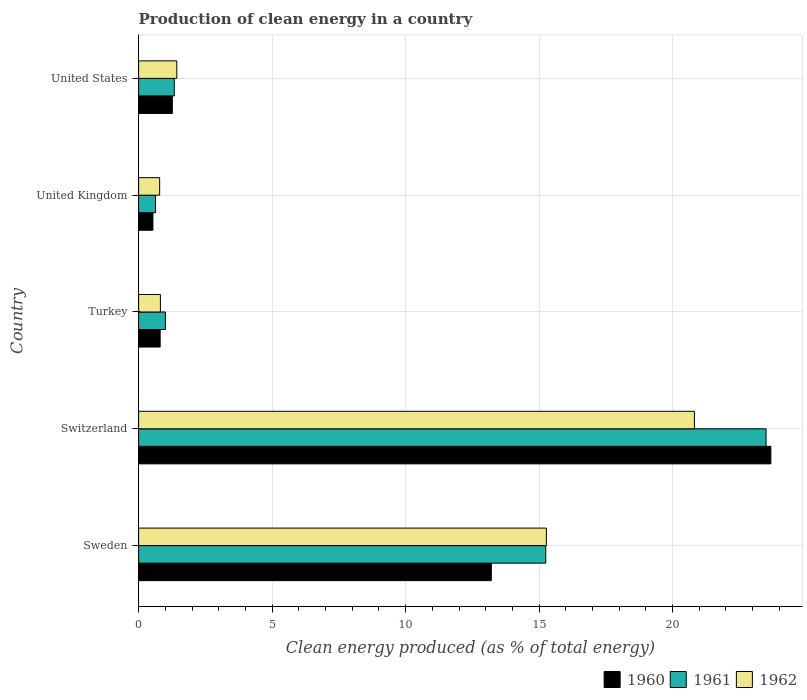How many different coloured bars are there?
Your response must be concise. 3. Are the number of bars per tick equal to the number of legend labels?
Your response must be concise. Yes. How many bars are there on the 1st tick from the top?
Offer a terse response. 3. How many bars are there on the 2nd tick from the bottom?
Offer a terse response. 3. What is the label of the 4th group of bars from the top?
Give a very brief answer. Switzerland. In how many cases, is the number of bars for a given country not equal to the number of legend labels?
Keep it short and to the point. 0. What is the percentage of clean energy produced in 1962 in Switzerland?
Your response must be concise. 20.82. Across all countries, what is the maximum percentage of clean energy produced in 1961?
Provide a short and direct response. 23.5. Across all countries, what is the minimum percentage of clean energy produced in 1960?
Your answer should be compact. 0.54. In which country was the percentage of clean energy produced in 1960 maximum?
Make the answer very short. Switzerland. In which country was the percentage of clean energy produced in 1960 minimum?
Your answer should be very brief. United Kingdom. What is the total percentage of clean energy produced in 1960 in the graph?
Keep it short and to the point. 39.5. What is the difference between the percentage of clean energy produced in 1962 in Turkey and that in United Kingdom?
Keep it short and to the point. 0.03. What is the difference between the percentage of clean energy produced in 1961 in United States and the percentage of clean energy produced in 1960 in Switzerland?
Your response must be concise. -22.35. What is the average percentage of clean energy produced in 1961 per country?
Provide a short and direct response. 8.34. What is the difference between the percentage of clean energy produced in 1961 and percentage of clean energy produced in 1960 in Switzerland?
Your answer should be very brief. -0.18. In how many countries, is the percentage of clean energy produced in 1961 greater than 11 %?
Keep it short and to the point. 2. What is the ratio of the percentage of clean energy produced in 1962 in Sweden to that in Switzerland?
Offer a very short reply. 0.73. What is the difference between the highest and the second highest percentage of clean energy produced in 1961?
Your answer should be compact. 8.25. What is the difference between the highest and the lowest percentage of clean energy produced in 1960?
Ensure brevity in your answer.  23.15. Is the sum of the percentage of clean energy produced in 1960 in Sweden and Turkey greater than the maximum percentage of clean energy produced in 1962 across all countries?
Ensure brevity in your answer.  No. What does the 2nd bar from the top in Sweden represents?
Your answer should be compact. 1961. What does the 3rd bar from the bottom in Switzerland represents?
Offer a terse response. 1962. Is it the case that in every country, the sum of the percentage of clean energy produced in 1962 and percentage of clean energy produced in 1960 is greater than the percentage of clean energy produced in 1961?
Provide a short and direct response. Yes. What is the difference between two consecutive major ticks on the X-axis?
Provide a succinct answer. 5. Where does the legend appear in the graph?
Your answer should be compact. Bottom right. What is the title of the graph?
Your response must be concise. Production of clean energy in a country. What is the label or title of the X-axis?
Keep it short and to the point. Clean energy produced (as % of total energy). What is the Clean energy produced (as % of total energy) of 1960 in Sweden?
Give a very brief answer. 13.21. What is the Clean energy produced (as % of total energy) in 1961 in Sweden?
Give a very brief answer. 15.25. What is the Clean energy produced (as % of total energy) of 1962 in Sweden?
Ensure brevity in your answer.  15.27. What is the Clean energy produced (as % of total energy) in 1960 in Switzerland?
Your answer should be compact. 23.68. What is the Clean energy produced (as % of total energy) in 1961 in Switzerland?
Your answer should be very brief. 23.5. What is the Clean energy produced (as % of total energy) of 1962 in Switzerland?
Your response must be concise. 20.82. What is the Clean energy produced (as % of total energy) in 1960 in Turkey?
Your response must be concise. 0.81. What is the Clean energy produced (as % of total energy) in 1961 in Turkey?
Give a very brief answer. 1. What is the Clean energy produced (as % of total energy) in 1962 in Turkey?
Provide a short and direct response. 0.82. What is the Clean energy produced (as % of total energy) in 1960 in United Kingdom?
Provide a short and direct response. 0.54. What is the Clean energy produced (as % of total energy) of 1961 in United Kingdom?
Offer a very short reply. 0.63. What is the Clean energy produced (as % of total energy) in 1962 in United Kingdom?
Ensure brevity in your answer.  0.79. What is the Clean energy produced (as % of total energy) in 1960 in United States?
Give a very brief answer. 1.26. What is the Clean energy produced (as % of total energy) of 1961 in United States?
Provide a short and direct response. 1.33. What is the Clean energy produced (as % of total energy) of 1962 in United States?
Your response must be concise. 1.43. Across all countries, what is the maximum Clean energy produced (as % of total energy) in 1960?
Your answer should be very brief. 23.68. Across all countries, what is the maximum Clean energy produced (as % of total energy) of 1961?
Offer a terse response. 23.5. Across all countries, what is the maximum Clean energy produced (as % of total energy) of 1962?
Give a very brief answer. 20.82. Across all countries, what is the minimum Clean energy produced (as % of total energy) of 1960?
Give a very brief answer. 0.54. Across all countries, what is the minimum Clean energy produced (as % of total energy) of 1961?
Your response must be concise. 0.63. Across all countries, what is the minimum Clean energy produced (as % of total energy) in 1962?
Your answer should be very brief. 0.79. What is the total Clean energy produced (as % of total energy) of 1960 in the graph?
Your answer should be very brief. 39.5. What is the total Clean energy produced (as % of total energy) of 1961 in the graph?
Offer a terse response. 41.72. What is the total Clean energy produced (as % of total energy) of 1962 in the graph?
Ensure brevity in your answer.  39.12. What is the difference between the Clean energy produced (as % of total energy) of 1960 in Sweden and that in Switzerland?
Give a very brief answer. -10.47. What is the difference between the Clean energy produced (as % of total energy) in 1961 in Sweden and that in Switzerland?
Give a very brief answer. -8.25. What is the difference between the Clean energy produced (as % of total energy) in 1962 in Sweden and that in Switzerland?
Your answer should be compact. -5.55. What is the difference between the Clean energy produced (as % of total energy) in 1960 in Sweden and that in Turkey?
Offer a very short reply. 12.4. What is the difference between the Clean energy produced (as % of total energy) of 1961 in Sweden and that in Turkey?
Your response must be concise. 14.25. What is the difference between the Clean energy produced (as % of total energy) in 1962 in Sweden and that in Turkey?
Provide a succinct answer. 14.46. What is the difference between the Clean energy produced (as % of total energy) of 1960 in Sweden and that in United Kingdom?
Your answer should be very brief. 12.68. What is the difference between the Clean energy produced (as % of total energy) in 1961 in Sweden and that in United Kingdom?
Offer a terse response. 14.62. What is the difference between the Clean energy produced (as % of total energy) in 1962 in Sweden and that in United Kingdom?
Offer a terse response. 14.49. What is the difference between the Clean energy produced (as % of total energy) in 1960 in Sweden and that in United States?
Your response must be concise. 11.95. What is the difference between the Clean energy produced (as % of total energy) of 1961 in Sweden and that in United States?
Your response must be concise. 13.92. What is the difference between the Clean energy produced (as % of total energy) in 1962 in Sweden and that in United States?
Provide a succinct answer. 13.84. What is the difference between the Clean energy produced (as % of total energy) of 1960 in Switzerland and that in Turkey?
Provide a short and direct response. 22.88. What is the difference between the Clean energy produced (as % of total energy) of 1961 in Switzerland and that in Turkey?
Offer a terse response. 22.5. What is the difference between the Clean energy produced (as % of total energy) in 1962 in Switzerland and that in Turkey?
Your answer should be very brief. 20. What is the difference between the Clean energy produced (as % of total energy) of 1960 in Switzerland and that in United Kingdom?
Ensure brevity in your answer.  23.15. What is the difference between the Clean energy produced (as % of total energy) of 1961 in Switzerland and that in United Kingdom?
Offer a terse response. 22.87. What is the difference between the Clean energy produced (as % of total energy) in 1962 in Switzerland and that in United Kingdom?
Provide a short and direct response. 20.03. What is the difference between the Clean energy produced (as % of total energy) in 1960 in Switzerland and that in United States?
Keep it short and to the point. 22.42. What is the difference between the Clean energy produced (as % of total energy) in 1961 in Switzerland and that in United States?
Your answer should be compact. 22.17. What is the difference between the Clean energy produced (as % of total energy) of 1962 in Switzerland and that in United States?
Make the answer very short. 19.39. What is the difference between the Clean energy produced (as % of total energy) in 1960 in Turkey and that in United Kingdom?
Your answer should be very brief. 0.27. What is the difference between the Clean energy produced (as % of total energy) in 1961 in Turkey and that in United Kingdom?
Keep it short and to the point. 0.37. What is the difference between the Clean energy produced (as % of total energy) of 1962 in Turkey and that in United Kingdom?
Ensure brevity in your answer.  0.03. What is the difference between the Clean energy produced (as % of total energy) in 1960 in Turkey and that in United States?
Offer a terse response. -0.46. What is the difference between the Clean energy produced (as % of total energy) in 1961 in Turkey and that in United States?
Your response must be concise. -0.33. What is the difference between the Clean energy produced (as % of total energy) of 1962 in Turkey and that in United States?
Your answer should be very brief. -0.61. What is the difference between the Clean energy produced (as % of total energy) of 1960 in United Kingdom and that in United States?
Your answer should be compact. -0.73. What is the difference between the Clean energy produced (as % of total energy) of 1961 in United Kingdom and that in United States?
Give a very brief answer. -0.7. What is the difference between the Clean energy produced (as % of total energy) in 1962 in United Kingdom and that in United States?
Make the answer very short. -0.64. What is the difference between the Clean energy produced (as % of total energy) of 1960 in Sweden and the Clean energy produced (as % of total energy) of 1961 in Switzerland?
Offer a very short reply. -10.29. What is the difference between the Clean energy produced (as % of total energy) of 1960 in Sweden and the Clean energy produced (as % of total energy) of 1962 in Switzerland?
Provide a short and direct response. -7.61. What is the difference between the Clean energy produced (as % of total energy) in 1961 in Sweden and the Clean energy produced (as % of total energy) in 1962 in Switzerland?
Provide a succinct answer. -5.57. What is the difference between the Clean energy produced (as % of total energy) in 1960 in Sweden and the Clean energy produced (as % of total energy) in 1961 in Turkey?
Keep it short and to the point. 12.21. What is the difference between the Clean energy produced (as % of total energy) of 1960 in Sweden and the Clean energy produced (as % of total energy) of 1962 in Turkey?
Your response must be concise. 12.4. What is the difference between the Clean energy produced (as % of total energy) in 1961 in Sweden and the Clean energy produced (as % of total energy) in 1962 in Turkey?
Make the answer very short. 14.43. What is the difference between the Clean energy produced (as % of total energy) of 1960 in Sweden and the Clean energy produced (as % of total energy) of 1961 in United Kingdom?
Offer a terse response. 12.58. What is the difference between the Clean energy produced (as % of total energy) of 1960 in Sweden and the Clean energy produced (as % of total energy) of 1962 in United Kingdom?
Your answer should be compact. 12.42. What is the difference between the Clean energy produced (as % of total energy) in 1961 in Sweden and the Clean energy produced (as % of total energy) in 1962 in United Kingdom?
Your answer should be compact. 14.46. What is the difference between the Clean energy produced (as % of total energy) in 1960 in Sweden and the Clean energy produced (as % of total energy) in 1961 in United States?
Offer a terse response. 11.88. What is the difference between the Clean energy produced (as % of total energy) in 1960 in Sweden and the Clean energy produced (as % of total energy) in 1962 in United States?
Make the answer very short. 11.78. What is the difference between the Clean energy produced (as % of total energy) of 1961 in Sweden and the Clean energy produced (as % of total energy) of 1962 in United States?
Provide a succinct answer. 13.82. What is the difference between the Clean energy produced (as % of total energy) in 1960 in Switzerland and the Clean energy produced (as % of total energy) in 1961 in Turkey?
Offer a very short reply. 22.68. What is the difference between the Clean energy produced (as % of total energy) of 1960 in Switzerland and the Clean energy produced (as % of total energy) of 1962 in Turkey?
Your response must be concise. 22.87. What is the difference between the Clean energy produced (as % of total energy) of 1961 in Switzerland and the Clean energy produced (as % of total energy) of 1962 in Turkey?
Make the answer very short. 22.69. What is the difference between the Clean energy produced (as % of total energy) of 1960 in Switzerland and the Clean energy produced (as % of total energy) of 1961 in United Kingdom?
Make the answer very short. 23.05. What is the difference between the Clean energy produced (as % of total energy) in 1960 in Switzerland and the Clean energy produced (as % of total energy) in 1962 in United Kingdom?
Offer a terse response. 22.89. What is the difference between the Clean energy produced (as % of total energy) in 1961 in Switzerland and the Clean energy produced (as % of total energy) in 1962 in United Kingdom?
Keep it short and to the point. 22.71. What is the difference between the Clean energy produced (as % of total energy) of 1960 in Switzerland and the Clean energy produced (as % of total energy) of 1961 in United States?
Ensure brevity in your answer.  22.35. What is the difference between the Clean energy produced (as % of total energy) of 1960 in Switzerland and the Clean energy produced (as % of total energy) of 1962 in United States?
Your answer should be very brief. 22.25. What is the difference between the Clean energy produced (as % of total energy) in 1961 in Switzerland and the Clean energy produced (as % of total energy) in 1962 in United States?
Ensure brevity in your answer.  22.07. What is the difference between the Clean energy produced (as % of total energy) in 1960 in Turkey and the Clean energy produced (as % of total energy) in 1961 in United Kingdom?
Provide a short and direct response. 0.17. What is the difference between the Clean energy produced (as % of total energy) in 1960 in Turkey and the Clean energy produced (as % of total energy) in 1962 in United Kingdom?
Your answer should be very brief. 0.02. What is the difference between the Clean energy produced (as % of total energy) of 1961 in Turkey and the Clean energy produced (as % of total energy) of 1962 in United Kingdom?
Your response must be concise. 0.21. What is the difference between the Clean energy produced (as % of total energy) in 1960 in Turkey and the Clean energy produced (as % of total energy) in 1961 in United States?
Ensure brevity in your answer.  -0.53. What is the difference between the Clean energy produced (as % of total energy) in 1960 in Turkey and the Clean energy produced (as % of total energy) in 1962 in United States?
Ensure brevity in your answer.  -0.62. What is the difference between the Clean energy produced (as % of total energy) in 1961 in Turkey and the Clean energy produced (as % of total energy) in 1962 in United States?
Keep it short and to the point. -0.43. What is the difference between the Clean energy produced (as % of total energy) of 1960 in United Kingdom and the Clean energy produced (as % of total energy) of 1961 in United States?
Ensure brevity in your answer.  -0.8. What is the difference between the Clean energy produced (as % of total energy) in 1960 in United Kingdom and the Clean energy produced (as % of total energy) in 1962 in United States?
Your answer should be compact. -0.89. What is the difference between the Clean energy produced (as % of total energy) of 1961 in United Kingdom and the Clean energy produced (as % of total energy) of 1962 in United States?
Ensure brevity in your answer.  -0.8. What is the average Clean energy produced (as % of total energy) in 1960 per country?
Offer a very short reply. 7.9. What is the average Clean energy produced (as % of total energy) of 1961 per country?
Give a very brief answer. 8.34. What is the average Clean energy produced (as % of total energy) of 1962 per country?
Your response must be concise. 7.83. What is the difference between the Clean energy produced (as % of total energy) of 1960 and Clean energy produced (as % of total energy) of 1961 in Sweden?
Provide a short and direct response. -2.04. What is the difference between the Clean energy produced (as % of total energy) of 1960 and Clean energy produced (as % of total energy) of 1962 in Sweden?
Your answer should be very brief. -2.06. What is the difference between the Clean energy produced (as % of total energy) in 1961 and Clean energy produced (as % of total energy) in 1962 in Sweden?
Provide a succinct answer. -0.02. What is the difference between the Clean energy produced (as % of total energy) in 1960 and Clean energy produced (as % of total energy) in 1961 in Switzerland?
Your answer should be compact. 0.18. What is the difference between the Clean energy produced (as % of total energy) in 1960 and Clean energy produced (as % of total energy) in 1962 in Switzerland?
Ensure brevity in your answer.  2.86. What is the difference between the Clean energy produced (as % of total energy) of 1961 and Clean energy produced (as % of total energy) of 1962 in Switzerland?
Provide a succinct answer. 2.68. What is the difference between the Clean energy produced (as % of total energy) of 1960 and Clean energy produced (as % of total energy) of 1961 in Turkey?
Offer a terse response. -0.2. What is the difference between the Clean energy produced (as % of total energy) in 1960 and Clean energy produced (as % of total energy) in 1962 in Turkey?
Provide a succinct answer. -0.01. What is the difference between the Clean energy produced (as % of total energy) of 1961 and Clean energy produced (as % of total energy) of 1962 in Turkey?
Your response must be concise. 0.19. What is the difference between the Clean energy produced (as % of total energy) of 1960 and Clean energy produced (as % of total energy) of 1961 in United Kingdom?
Your answer should be compact. -0.1. What is the difference between the Clean energy produced (as % of total energy) in 1960 and Clean energy produced (as % of total energy) in 1962 in United Kingdom?
Offer a terse response. -0.25. What is the difference between the Clean energy produced (as % of total energy) in 1961 and Clean energy produced (as % of total energy) in 1962 in United Kingdom?
Provide a succinct answer. -0.16. What is the difference between the Clean energy produced (as % of total energy) in 1960 and Clean energy produced (as % of total energy) in 1961 in United States?
Provide a short and direct response. -0.07. What is the difference between the Clean energy produced (as % of total energy) of 1960 and Clean energy produced (as % of total energy) of 1962 in United States?
Offer a terse response. -0.17. What is the difference between the Clean energy produced (as % of total energy) in 1961 and Clean energy produced (as % of total energy) in 1962 in United States?
Give a very brief answer. -0.1. What is the ratio of the Clean energy produced (as % of total energy) in 1960 in Sweden to that in Switzerland?
Your answer should be very brief. 0.56. What is the ratio of the Clean energy produced (as % of total energy) in 1961 in Sweden to that in Switzerland?
Your answer should be very brief. 0.65. What is the ratio of the Clean energy produced (as % of total energy) in 1962 in Sweden to that in Switzerland?
Your response must be concise. 0.73. What is the ratio of the Clean energy produced (as % of total energy) in 1960 in Sweden to that in Turkey?
Your answer should be compact. 16.39. What is the ratio of the Clean energy produced (as % of total energy) of 1961 in Sweden to that in Turkey?
Ensure brevity in your answer.  15.21. What is the ratio of the Clean energy produced (as % of total energy) in 1962 in Sweden to that in Turkey?
Give a very brief answer. 18.73. What is the ratio of the Clean energy produced (as % of total energy) of 1960 in Sweden to that in United Kingdom?
Make the answer very short. 24.68. What is the ratio of the Clean energy produced (as % of total energy) in 1961 in Sweden to that in United Kingdom?
Offer a very short reply. 24.15. What is the ratio of the Clean energy produced (as % of total energy) of 1962 in Sweden to that in United Kingdom?
Your answer should be very brief. 19.39. What is the ratio of the Clean energy produced (as % of total energy) in 1960 in Sweden to that in United States?
Make the answer very short. 10.47. What is the ratio of the Clean energy produced (as % of total energy) in 1961 in Sweden to that in United States?
Offer a terse response. 11.43. What is the ratio of the Clean energy produced (as % of total energy) in 1962 in Sweden to that in United States?
Your answer should be very brief. 10.68. What is the ratio of the Clean energy produced (as % of total energy) in 1960 in Switzerland to that in Turkey?
Keep it short and to the point. 29.38. What is the ratio of the Clean energy produced (as % of total energy) in 1961 in Switzerland to that in Turkey?
Give a very brief answer. 23.44. What is the ratio of the Clean energy produced (as % of total energy) in 1962 in Switzerland to that in Turkey?
Offer a terse response. 25.53. What is the ratio of the Clean energy produced (as % of total energy) of 1960 in Switzerland to that in United Kingdom?
Your answer should be compact. 44.24. What is the ratio of the Clean energy produced (as % of total energy) in 1961 in Switzerland to that in United Kingdom?
Provide a short and direct response. 37.21. What is the ratio of the Clean energy produced (as % of total energy) in 1962 in Switzerland to that in United Kingdom?
Provide a succinct answer. 26.43. What is the ratio of the Clean energy produced (as % of total energy) of 1960 in Switzerland to that in United States?
Make the answer very short. 18.78. What is the ratio of the Clean energy produced (as % of total energy) in 1961 in Switzerland to that in United States?
Ensure brevity in your answer.  17.61. What is the ratio of the Clean energy produced (as % of total energy) in 1962 in Switzerland to that in United States?
Make the answer very short. 14.56. What is the ratio of the Clean energy produced (as % of total energy) of 1960 in Turkey to that in United Kingdom?
Offer a very short reply. 1.51. What is the ratio of the Clean energy produced (as % of total energy) of 1961 in Turkey to that in United Kingdom?
Offer a very short reply. 1.59. What is the ratio of the Clean energy produced (as % of total energy) in 1962 in Turkey to that in United Kingdom?
Give a very brief answer. 1.04. What is the ratio of the Clean energy produced (as % of total energy) in 1960 in Turkey to that in United States?
Ensure brevity in your answer.  0.64. What is the ratio of the Clean energy produced (as % of total energy) in 1961 in Turkey to that in United States?
Your answer should be very brief. 0.75. What is the ratio of the Clean energy produced (as % of total energy) in 1962 in Turkey to that in United States?
Make the answer very short. 0.57. What is the ratio of the Clean energy produced (as % of total energy) in 1960 in United Kingdom to that in United States?
Your answer should be very brief. 0.42. What is the ratio of the Clean energy produced (as % of total energy) of 1961 in United Kingdom to that in United States?
Your answer should be compact. 0.47. What is the ratio of the Clean energy produced (as % of total energy) in 1962 in United Kingdom to that in United States?
Make the answer very short. 0.55. What is the difference between the highest and the second highest Clean energy produced (as % of total energy) in 1960?
Make the answer very short. 10.47. What is the difference between the highest and the second highest Clean energy produced (as % of total energy) of 1961?
Provide a succinct answer. 8.25. What is the difference between the highest and the second highest Clean energy produced (as % of total energy) of 1962?
Offer a terse response. 5.55. What is the difference between the highest and the lowest Clean energy produced (as % of total energy) of 1960?
Keep it short and to the point. 23.15. What is the difference between the highest and the lowest Clean energy produced (as % of total energy) in 1961?
Your response must be concise. 22.87. What is the difference between the highest and the lowest Clean energy produced (as % of total energy) in 1962?
Keep it short and to the point. 20.03. 